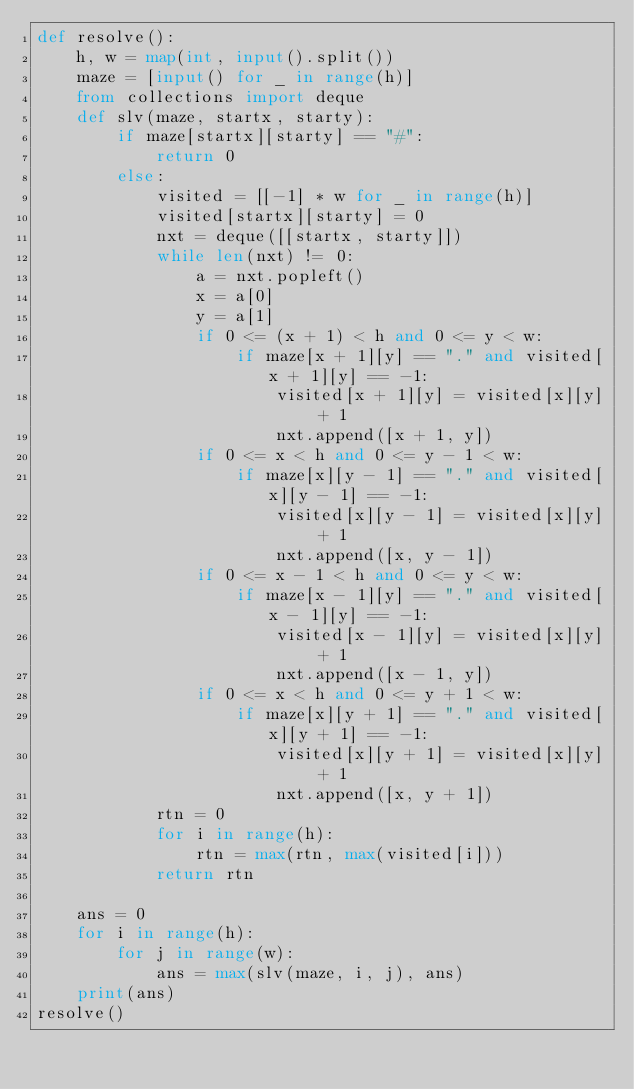Convert code to text. <code><loc_0><loc_0><loc_500><loc_500><_Python_>def resolve():
    h, w = map(int, input().split())
    maze = [input() for _ in range(h)]
    from collections import deque
    def slv(maze, startx, starty):
        if maze[startx][starty] == "#":
            return 0
        else:
            visited = [[-1] * w for _ in range(h)]
            visited[startx][starty] = 0
            nxt = deque([[startx, starty]])
            while len(nxt) != 0:
                a = nxt.popleft()
                x = a[0]
                y = a[1]
                if 0 <= (x + 1) < h and 0 <= y < w:
                    if maze[x + 1][y] == "." and visited[x + 1][y] == -1:
                        visited[x + 1][y] = visited[x][y] + 1
                        nxt.append([x + 1, y])
                if 0 <= x < h and 0 <= y - 1 < w:
                    if maze[x][y - 1] == "." and visited[x][y - 1] == -1:
                        visited[x][y - 1] = visited[x][y] + 1
                        nxt.append([x, y - 1])
                if 0 <= x - 1 < h and 0 <= y < w:
                    if maze[x - 1][y] == "." and visited[x - 1][y] == -1:
                        visited[x - 1][y] = visited[x][y] + 1
                        nxt.append([x - 1, y])
                if 0 <= x < h and 0 <= y + 1 < w:
                    if maze[x][y + 1] == "." and visited[x][y + 1] == -1:
                        visited[x][y + 1] = visited[x][y] + 1
                        nxt.append([x, y + 1])
            rtn = 0
            for i in range(h):
                rtn = max(rtn, max(visited[i]))
            return rtn

    ans = 0
    for i in range(h):
        for j in range(w):
            ans = max(slv(maze, i, j), ans)
    print(ans)
resolve()</code> 